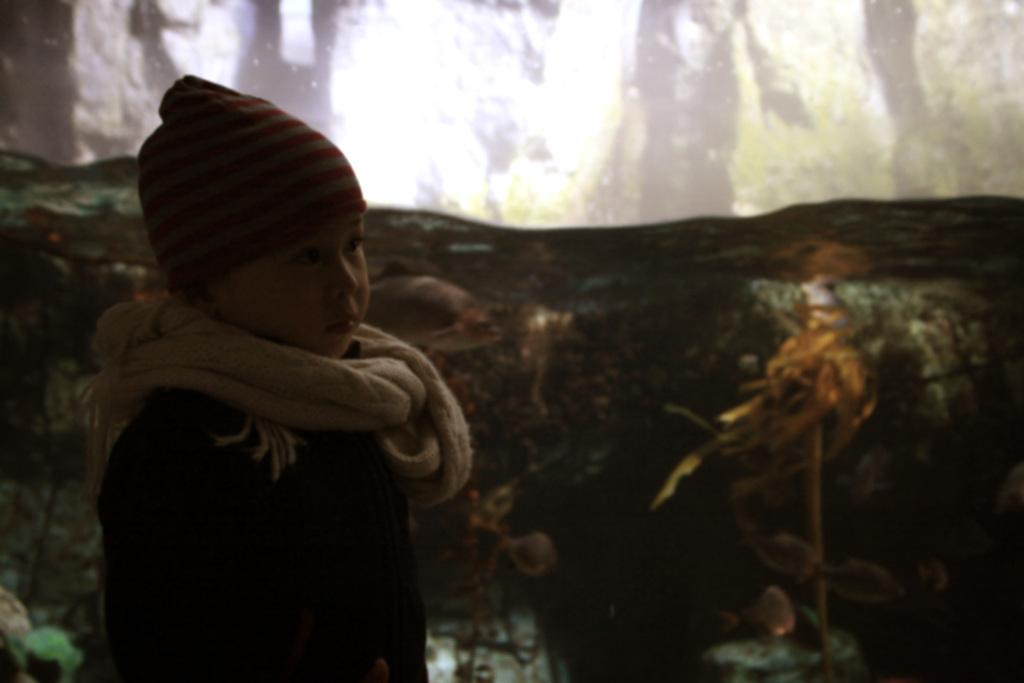What is the main subject of the image? There is a boy standing in the image. Can you describe the background of the image? The background of the image is blurred. What type of ink can be seen dripping from the van in the image? There is no van or ink present in the image. How many snails can be seen crawling on the boy in the image? There are no snails present in the image. 